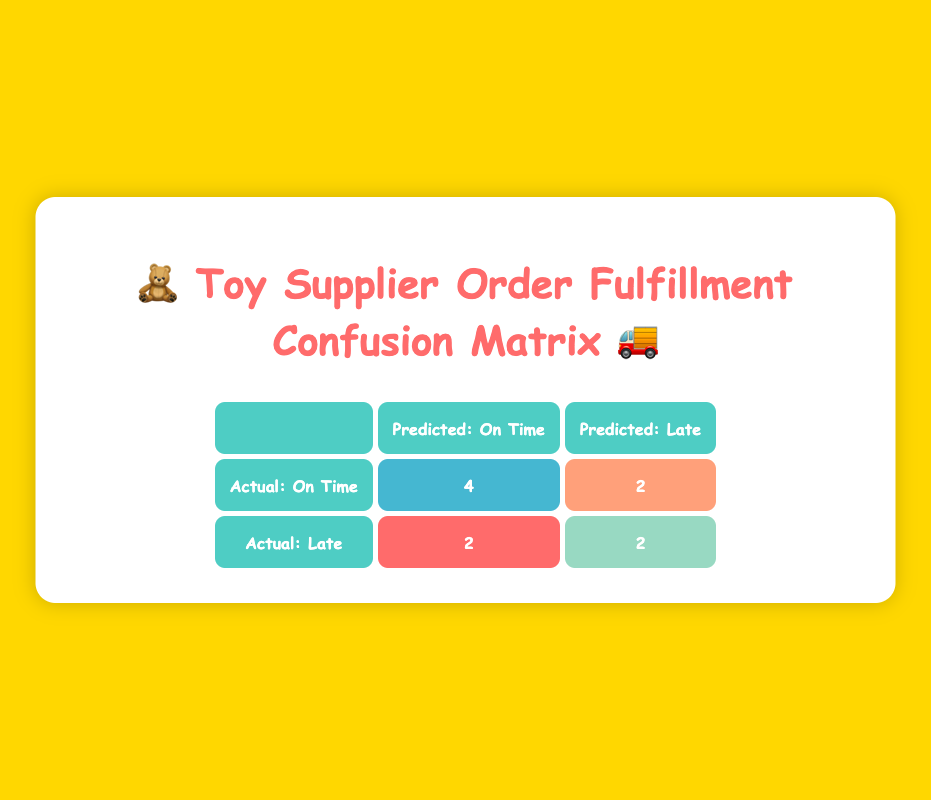What is the number of suppliers predicted to be "On Time" and actually delivered "On Time"? To find the number of suppliers predicted to be "On Time" and also delivered "On Time," we refer to the True Positive cell. The value in this cell represents the count of suppliers who fall into this category, which is 4.
Answer: 4 How many suppliers were predicted to be "Late" but delivered "On Time"? This query pertains to the False Positive cell, which identifies suppliers predicted to be "Late" but actually delivered "On Time". Referring to the table, this value is 2.
Answer: 2 What is the total number of suppliers? To determine the total number of suppliers listed, we sum up all the entries provided in the table. There are 10 suppliers in total based on the data.
Answer: 10 What percentage of suppliers delivered on time based on the actual status? To find the percentage of suppliers that delivered on time, we look at the total number of suppliers who delivered "On Time," which is 6 (4 true positives and 2 false negatives). The percentage is calculated by (6 delivered on time / 10 total suppliers) * 100 = 60%.
Answer: 60% Is it true that "KidsJoy Suppliers" was predicted to be "Late"? Checking the entry for "KidsJoy Suppliers," we see that their predicted status is listed as "Late." Thus, this statement is true.
Answer: Yes What is the difference between the number of true positives and true negatives? The number of true positives (4) and true negatives (2) needs to have a difference calculated. The difference is 4 - 2, which equals 2.
Answer: 2 Which supplier combination has the most discrepancies between predicted and actual delivery status? From analysis, "PlayMaterials Inc." and "KidsJoy Suppliers" both exemplify discrepancies, with one predicted "On Time" but delivered "Late" and the other predicted "Late" but delivered "On Time." Since both involve one notable discrepancy, we can say they tie for this characteristic.
Answer: PlayMaterials Inc. and KidsJoy Suppliers How many suppliers actually delivered "Late"? Looking at the actual status column, we see that there are 4 suppliers noted as delivering "Late"—2 true negatives and 2 false negatives.
Answer: 4 What is the ratio of true positives to false negatives? To calculate the ratio, we use the value of true positives, which is 4, and false negatives, which is 2. The ratio is 4:2, simplified to 2:1.
Answer: 2:1 